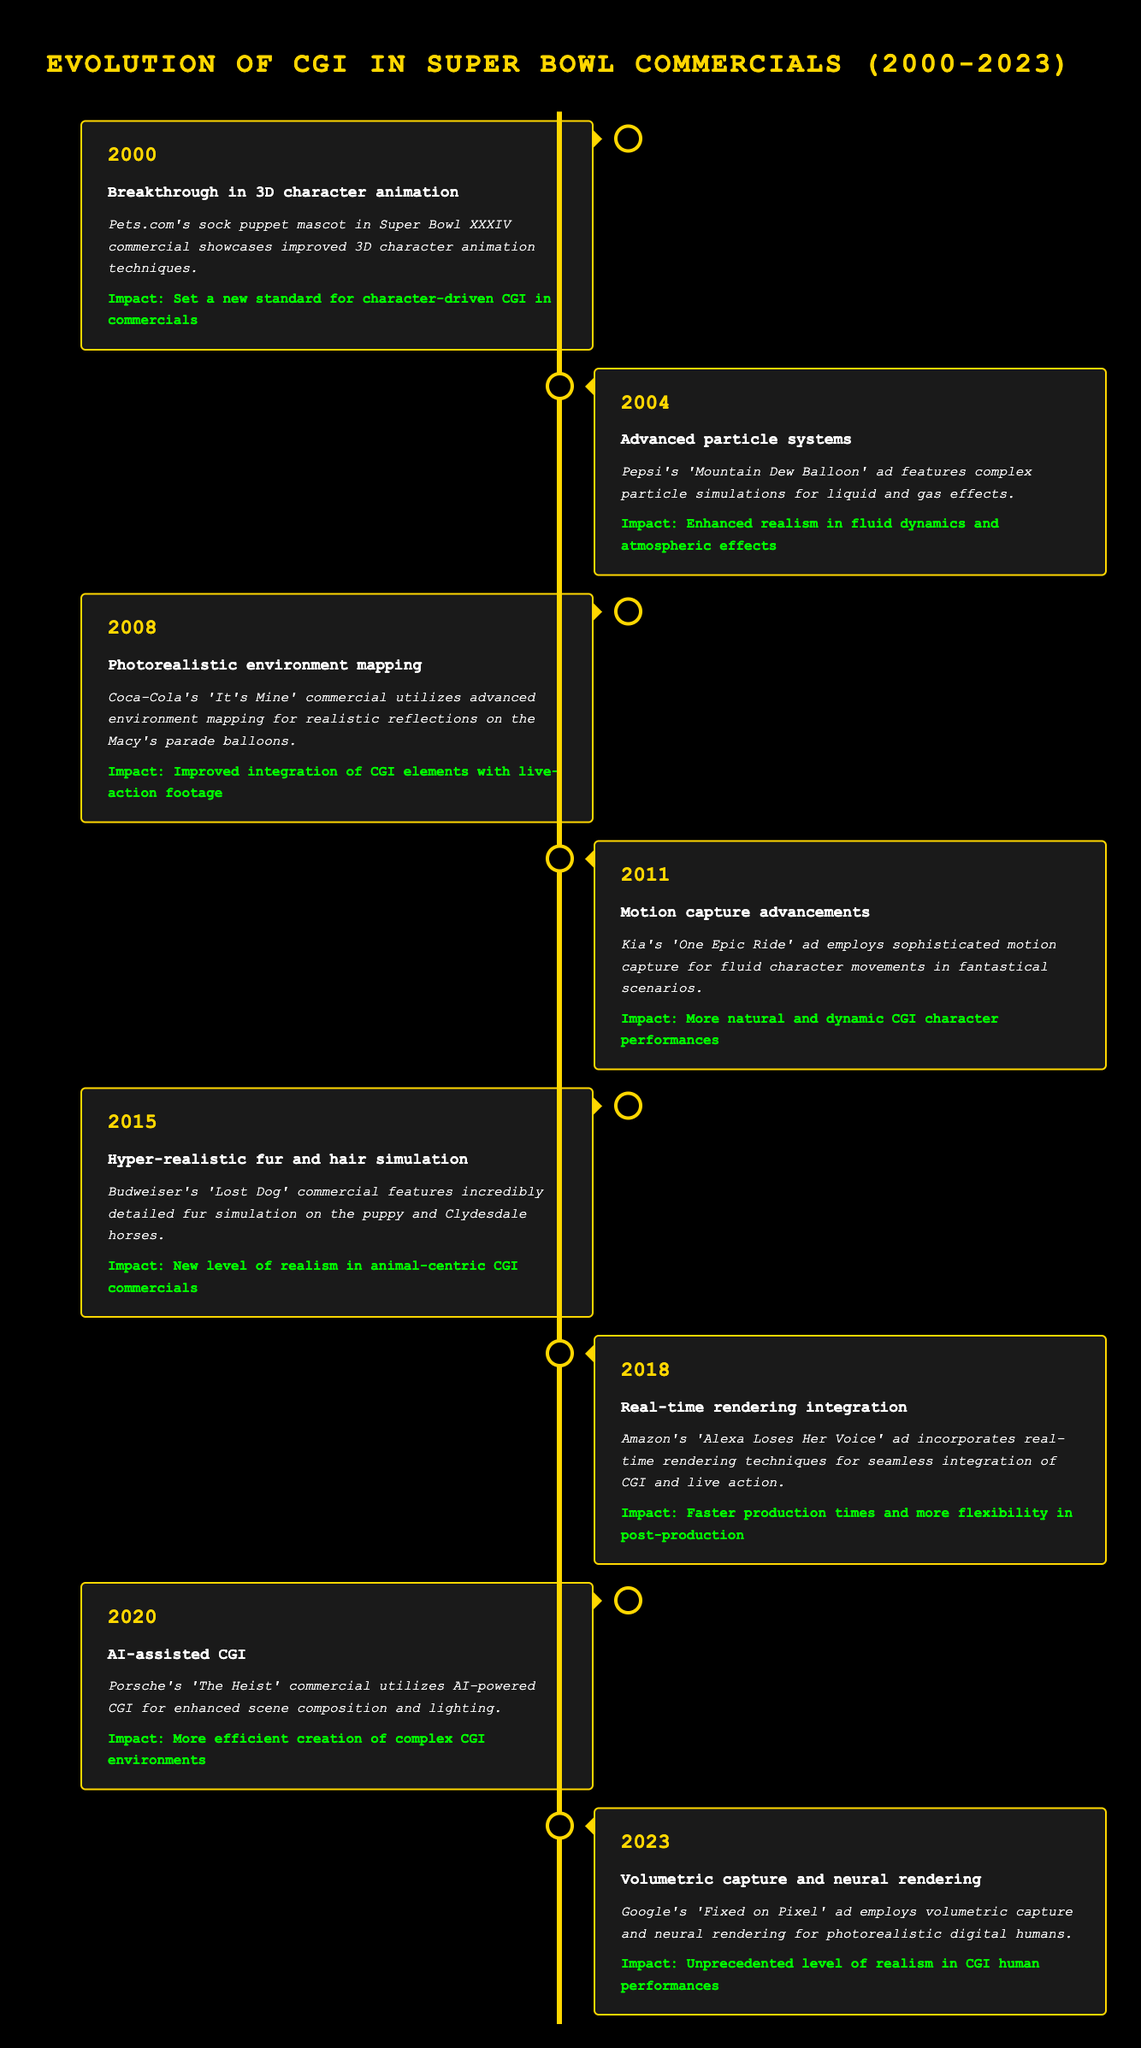What year did Pets.com showcase improved 3D character animation? The table indicates that Pets.com's sock puppet mascot showcased improved 3D character animation in the year 2000 during Super Bowl XXXIV.
Answer: 2000 Which commercial first introduced hyper-realistic fur and hair simulation? According to the table, Budweiser's 'Lost Dog' commercial introduced hyper-realistic fur and hair simulation in the year 2015.
Answer: Budweiser's 'Lost Dog' How many advancements in CGI occurred between 2000 and 2023? By counting the number of events listed from 2000 to 2023, there are a total of 8 advancements in CGI techniques.
Answer: 8 Is it true that real-time rendering integration was used before 2015? The table shows that real-time rendering integration was introduced in 2018, which means it was not used before 2015.
Answer: No What is the impact of AI-assisted CGI introduced in 2020? The impact of AI-assisted CGI, as stated in the table, is the more efficient creation of complex CGI environments.
Answer: More efficient creation of complex CGI environments Which technique introduced in 2023 focuses on photorealistic digital humans? The table specifies that volumetric capture and neural rendering introduced in 2023 focus on creating photorealistic digital humans in Google's 'Fixed on Pixel' ad.
Answer: Volumetric capture and neural rendering What is the average year of the advancements listed? To find the average, sum the years (2000 + 2004 + 2008 + 2011 + 2015 + 2018 + 2020 + 2023 = 2000 + 4 + 8 + 11 + 15 + 18 + 20 + 23 = 2099). There are 8 events, so the average year is 2099 / 8 = 262.375, or 2017.
Answer: 2017 What specific CGI advancement was highlighted in the Coca-Cola commercial? The table states that photorealistic environment mapping was utilized in Coca-Cola's 'It's Mine' commercial in 2008, which highlights the advancement.
Answer: Photorealistic environment mapping 